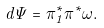Convert formula to latex. <formula><loc_0><loc_0><loc_500><loc_500>d \Psi = \pi _ { 1 } ^ { * } \pi ^ { * } \omega .</formula> 